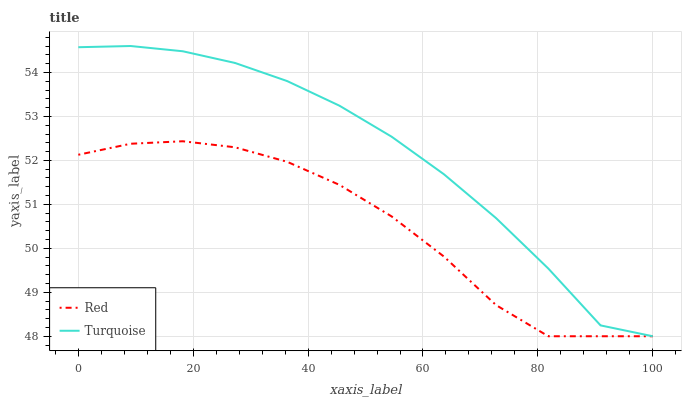Does Red have the minimum area under the curve?
Answer yes or no. Yes. Does Turquoise have the maximum area under the curve?
Answer yes or no. Yes. Does Red have the maximum area under the curve?
Answer yes or no. No. Is Turquoise the smoothest?
Answer yes or no. Yes. Is Red the roughest?
Answer yes or no. Yes. Is Red the smoothest?
Answer yes or no. No. Does Red have the highest value?
Answer yes or no. No. 